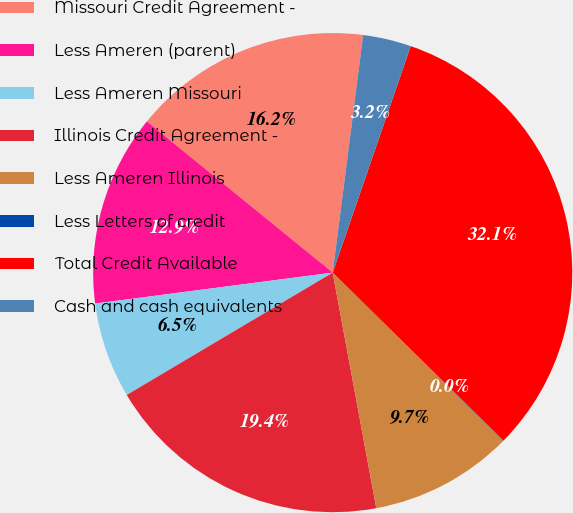<chart> <loc_0><loc_0><loc_500><loc_500><pie_chart><fcel>Missouri Credit Agreement -<fcel>Less Ameren (parent)<fcel>Less Ameren Missouri<fcel>Illinois Credit Agreement -<fcel>Less Ameren Illinois<fcel>Less Letters of credit<fcel>Total Credit Available<fcel>Cash and cash equivalents<nl><fcel>16.16%<fcel>12.93%<fcel>6.47%<fcel>19.38%<fcel>9.7%<fcel>0.02%<fcel>32.09%<fcel>3.25%<nl></chart> 